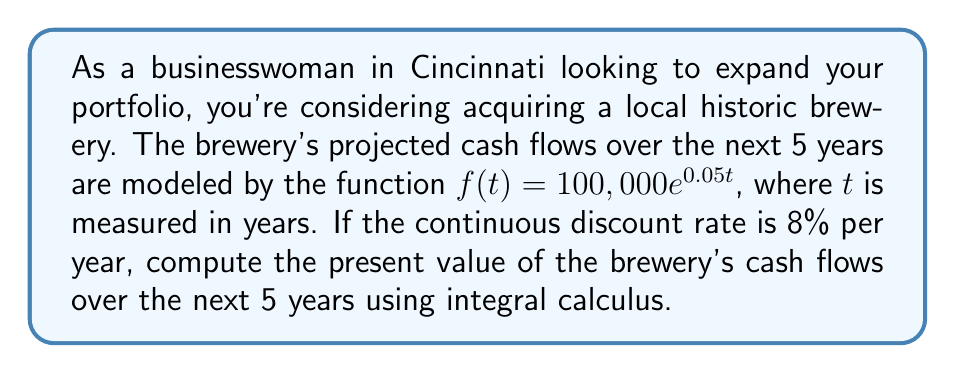Can you solve this math problem? To solve this problem, we need to use the present value formula for continuous cash flows:

$$PV = \int_0^T e^{-rt}f(t)dt$$

Where:
- $PV$ is the present value
- $T$ is the time horizon (5 years in this case)
- $r$ is the continuous discount rate (8% or 0.08)
- $f(t)$ is the cash flow function

Let's substitute our values:

$$PV = \int_0^5 e^{-0.08t}(100,000e^{0.05t})dt$$

Simplify:

$$PV = 100,000 \int_0^5 e^{(-0.08+0.05)t}dt$$
$$PV = 100,000 \int_0^5 e^{-0.03t}dt$$

Now we can integrate:

$$PV = 100,000 \left[-\frac{1}{0.03}e^{-0.03t}\right]_0^5$$

Evaluate the integral:

$$PV = 100,000 \left(-\frac{1}{0.03}e^{-0.03(5)} + \frac{1}{0.03}e^{-0.03(0)}\right)$$
$$PV = 100,000 \left(-\frac{1}{0.03}e^{-0.15} + \frac{1}{0.03}\right)$$

Simplify:

$$PV = \frac{100,000}{0.03}(1 - e^{-0.15})$$
$$PV = 3,333,333.33(1 - 0.8607)$$
$$PV = 3,333,333.33(0.1393)$$
$$PV = 464,333.33$$
Answer: The present value of the brewery's cash flows over the next 5 years is approximately $464,333.33. 